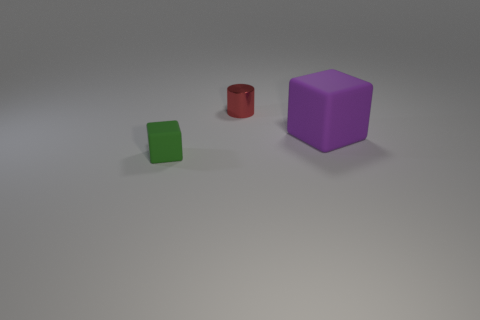Add 1 small cubes. How many objects exist? 4 Subtract all cylinders. How many objects are left? 2 Add 1 tiny things. How many tiny things exist? 3 Subtract 1 red cylinders. How many objects are left? 2 Subtract all cylinders. Subtract all large objects. How many objects are left? 1 Add 2 large purple things. How many large purple things are left? 3 